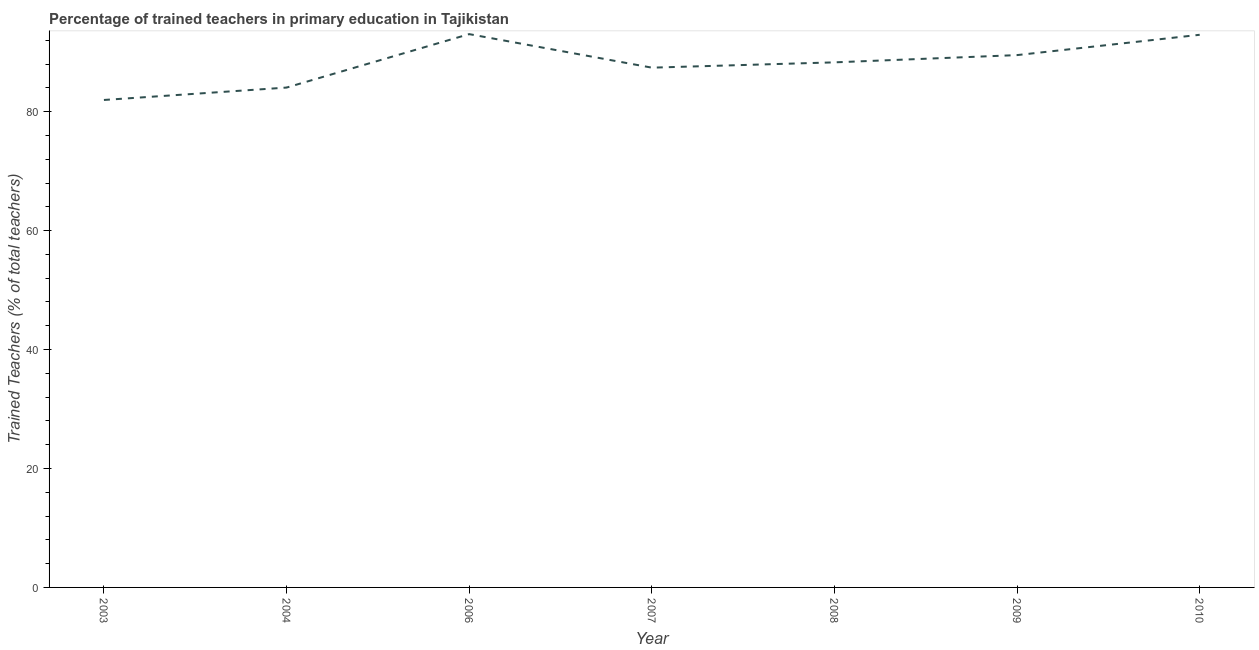What is the percentage of trained teachers in 2010?
Your response must be concise. 92.94. Across all years, what is the maximum percentage of trained teachers?
Your response must be concise. 93.05. Across all years, what is the minimum percentage of trained teachers?
Make the answer very short. 81.98. In which year was the percentage of trained teachers maximum?
Give a very brief answer. 2006. What is the sum of the percentage of trained teachers?
Give a very brief answer. 617.25. What is the difference between the percentage of trained teachers in 2003 and 2007?
Ensure brevity in your answer.  -5.43. What is the average percentage of trained teachers per year?
Give a very brief answer. 88.18. What is the median percentage of trained teachers?
Keep it short and to the point. 88.3. What is the ratio of the percentage of trained teachers in 2003 to that in 2010?
Provide a succinct answer. 0.88. What is the difference between the highest and the second highest percentage of trained teachers?
Provide a short and direct response. 0.11. What is the difference between the highest and the lowest percentage of trained teachers?
Provide a short and direct response. 11.07. Does the percentage of trained teachers monotonically increase over the years?
Offer a very short reply. No. How many years are there in the graph?
Make the answer very short. 7. What is the difference between two consecutive major ticks on the Y-axis?
Your answer should be compact. 20. Are the values on the major ticks of Y-axis written in scientific E-notation?
Provide a short and direct response. No. Does the graph contain any zero values?
Make the answer very short. No. What is the title of the graph?
Offer a terse response. Percentage of trained teachers in primary education in Tajikistan. What is the label or title of the X-axis?
Make the answer very short. Year. What is the label or title of the Y-axis?
Ensure brevity in your answer.  Trained Teachers (% of total teachers). What is the Trained Teachers (% of total teachers) in 2003?
Ensure brevity in your answer.  81.98. What is the Trained Teachers (% of total teachers) in 2004?
Your response must be concise. 84.06. What is the Trained Teachers (% of total teachers) in 2006?
Your answer should be very brief. 93.05. What is the Trained Teachers (% of total teachers) in 2007?
Give a very brief answer. 87.41. What is the Trained Teachers (% of total teachers) in 2008?
Give a very brief answer. 88.3. What is the Trained Teachers (% of total teachers) in 2009?
Offer a terse response. 89.52. What is the Trained Teachers (% of total teachers) of 2010?
Make the answer very short. 92.94. What is the difference between the Trained Teachers (% of total teachers) in 2003 and 2004?
Give a very brief answer. -2.09. What is the difference between the Trained Teachers (% of total teachers) in 2003 and 2006?
Make the answer very short. -11.07. What is the difference between the Trained Teachers (% of total teachers) in 2003 and 2007?
Keep it short and to the point. -5.43. What is the difference between the Trained Teachers (% of total teachers) in 2003 and 2008?
Provide a succinct answer. -6.32. What is the difference between the Trained Teachers (% of total teachers) in 2003 and 2009?
Your answer should be very brief. -7.54. What is the difference between the Trained Teachers (% of total teachers) in 2003 and 2010?
Your response must be concise. -10.96. What is the difference between the Trained Teachers (% of total teachers) in 2004 and 2006?
Make the answer very short. -8.99. What is the difference between the Trained Teachers (% of total teachers) in 2004 and 2007?
Ensure brevity in your answer.  -3.35. What is the difference between the Trained Teachers (% of total teachers) in 2004 and 2008?
Provide a succinct answer. -4.24. What is the difference between the Trained Teachers (% of total teachers) in 2004 and 2009?
Give a very brief answer. -5.46. What is the difference between the Trained Teachers (% of total teachers) in 2004 and 2010?
Offer a terse response. -8.88. What is the difference between the Trained Teachers (% of total teachers) in 2006 and 2007?
Ensure brevity in your answer.  5.64. What is the difference between the Trained Teachers (% of total teachers) in 2006 and 2008?
Offer a terse response. 4.75. What is the difference between the Trained Teachers (% of total teachers) in 2006 and 2009?
Make the answer very short. 3.53. What is the difference between the Trained Teachers (% of total teachers) in 2006 and 2010?
Provide a short and direct response. 0.11. What is the difference between the Trained Teachers (% of total teachers) in 2007 and 2008?
Provide a succinct answer. -0.89. What is the difference between the Trained Teachers (% of total teachers) in 2007 and 2009?
Your answer should be very brief. -2.11. What is the difference between the Trained Teachers (% of total teachers) in 2007 and 2010?
Your answer should be very brief. -5.53. What is the difference between the Trained Teachers (% of total teachers) in 2008 and 2009?
Keep it short and to the point. -1.22. What is the difference between the Trained Teachers (% of total teachers) in 2008 and 2010?
Your answer should be very brief. -4.64. What is the difference between the Trained Teachers (% of total teachers) in 2009 and 2010?
Make the answer very short. -3.42. What is the ratio of the Trained Teachers (% of total teachers) in 2003 to that in 2006?
Your response must be concise. 0.88. What is the ratio of the Trained Teachers (% of total teachers) in 2003 to that in 2007?
Keep it short and to the point. 0.94. What is the ratio of the Trained Teachers (% of total teachers) in 2003 to that in 2008?
Give a very brief answer. 0.93. What is the ratio of the Trained Teachers (% of total teachers) in 2003 to that in 2009?
Keep it short and to the point. 0.92. What is the ratio of the Trained Teachers (% of total teachers) in 2003 to that in 2010?
Offer a terse response. 0.88. What is the ratio of the Trained Teachers (% of total teachers) in 2004 to that in 2006?
Provide a succinct answer. 0.9. What is the ratio of the Trained Teachers (% of total teachers) in 2004 to that in 2009?
Keep it short and to the point. 0.94. What is the ratio of the Trained Teachers (% of total teachers) in 2004 to that in 2010?
Offer a terse response. 0.9. What is the ratio of the Trained Teachers (% of total teachers) in 2006 to that in 2007?
Provide a succinct answer. 1.06. What is the ratio of the Trained Teachers (% of total teachers) in 2006 to that in 2008?
Keep it short and to the point. 1.05. What is the ratio of the Trained Teachers (% of total teachers) in 2006 to that in 2009?
Your response must be concise. 1.04. What is the ratio of the Trained Teachers (% of total teachers) in 2006 to that in 2010?
Provide a short and direct response. 1. What is the ratio of the Trained Teachers (% of total teachers) in 2007 to that in 2008?
Your answer should be very brief. 0.99. What is the ratio of the Trained Teachers (% of total teachers) in 2007 to that in 2010?
Provide a succinct answer. 0.94. What is the ratio of the Trained Teachers (% of total teachers) in 2008 to that in 2009?
Provide a succinct answer. 0.99. What is the ratio of the Trained Teachers (% of total teachers) in 2008 to that in 2010?
Make the answer very short. 0.95. 